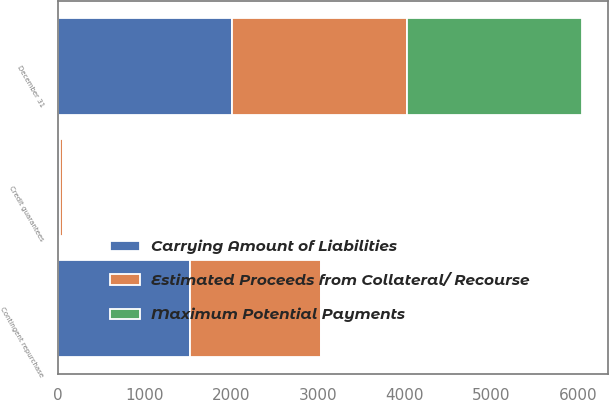<chart> <loc_0><loc_0><loc_500><loc_500><stacked_bar_chart><ecel><fcel>December 31<fcel>Contingent repurchase<fcel>Credit guarantees<nl><fcel>Carrying Amount of Liabilities<fcel>2015<fcel>1529<fcel>30<nl><fcel>Estimated Proceeds from Collateral/ Recourse<fcel>2015<fcel>1510<fcel>27<nl><fcel>Maximum Potential Payments<fcel>2015<fcel>7<fcel>2<nl></chart> 